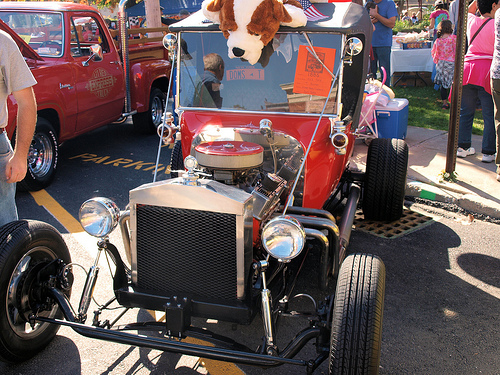<image>
Can you confirm if the car is behind the car? Yes. From this viewpoint, the car is positioned behind the car, with the car partially or fully occluding the car. Is there a pole behind the girl? No. The pole is not behind the girl. From this viewpoint, the pole appears to be positioned elsewhere in the scene. Is the stuff dog in front of the car? No. The stuff dog is not in front of the car. The spatial positioning shows a different relationship between these objects. 